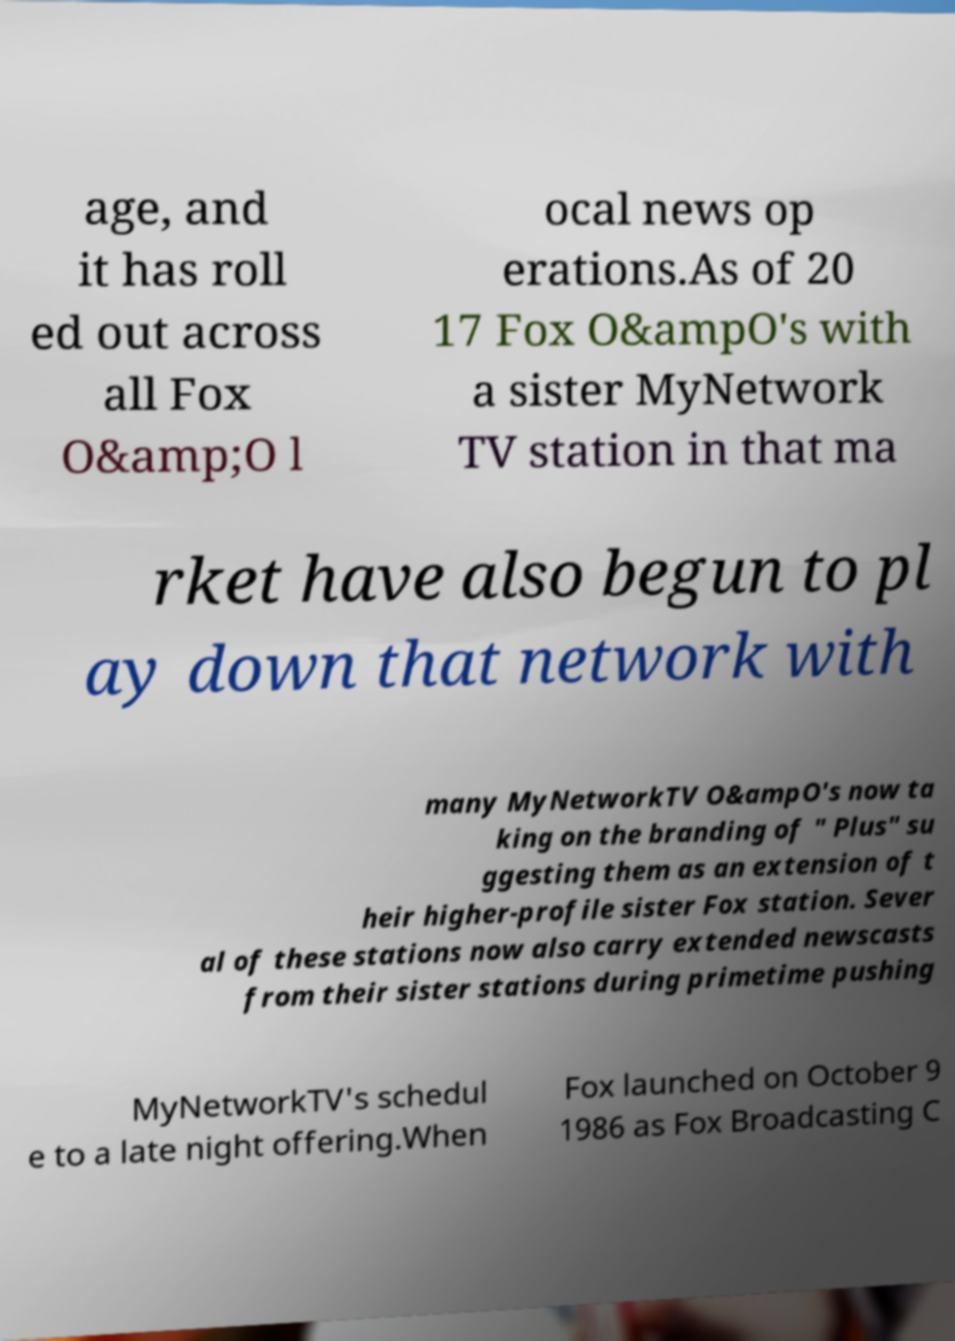What messages or text are displayed in this image? I need them in a readable, typed format. age, and it has roll ed out across all Fox O&amp;O l ocal news op erations.As of 20 17 Fox O&ampO's with a sister MyNetwork TV station in that ma rket have also begun to pl ay down that network with many MyNetworkTV O&ampO's now ta king on the branding of " Plus" su ggesting them as an extension of t heir higher-profile sister Fox station. Sever al of these stations now also carry extended newscasts from their sister stations during primetime pushing MyNetworkTV's schedul e to a late night offering.When Fox launched on October 9 1986 as Fox Broadcasting C 